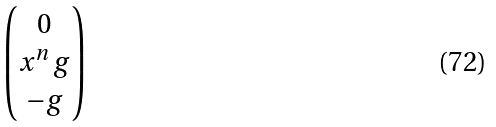<formula> <loc_0><loc_0><loc_500><loc_500>\begin{pmatrix} 0 \\ x ^ { n } \, g \\ - g \end{pmatrix}</formula> 